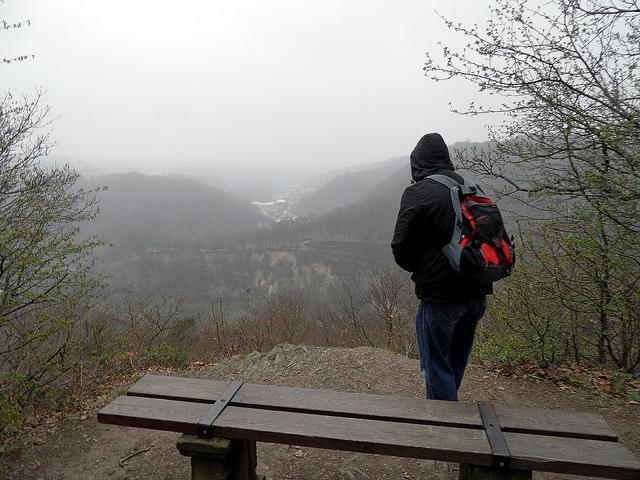How many power poles are there?
Give a very brief answer. 0. 